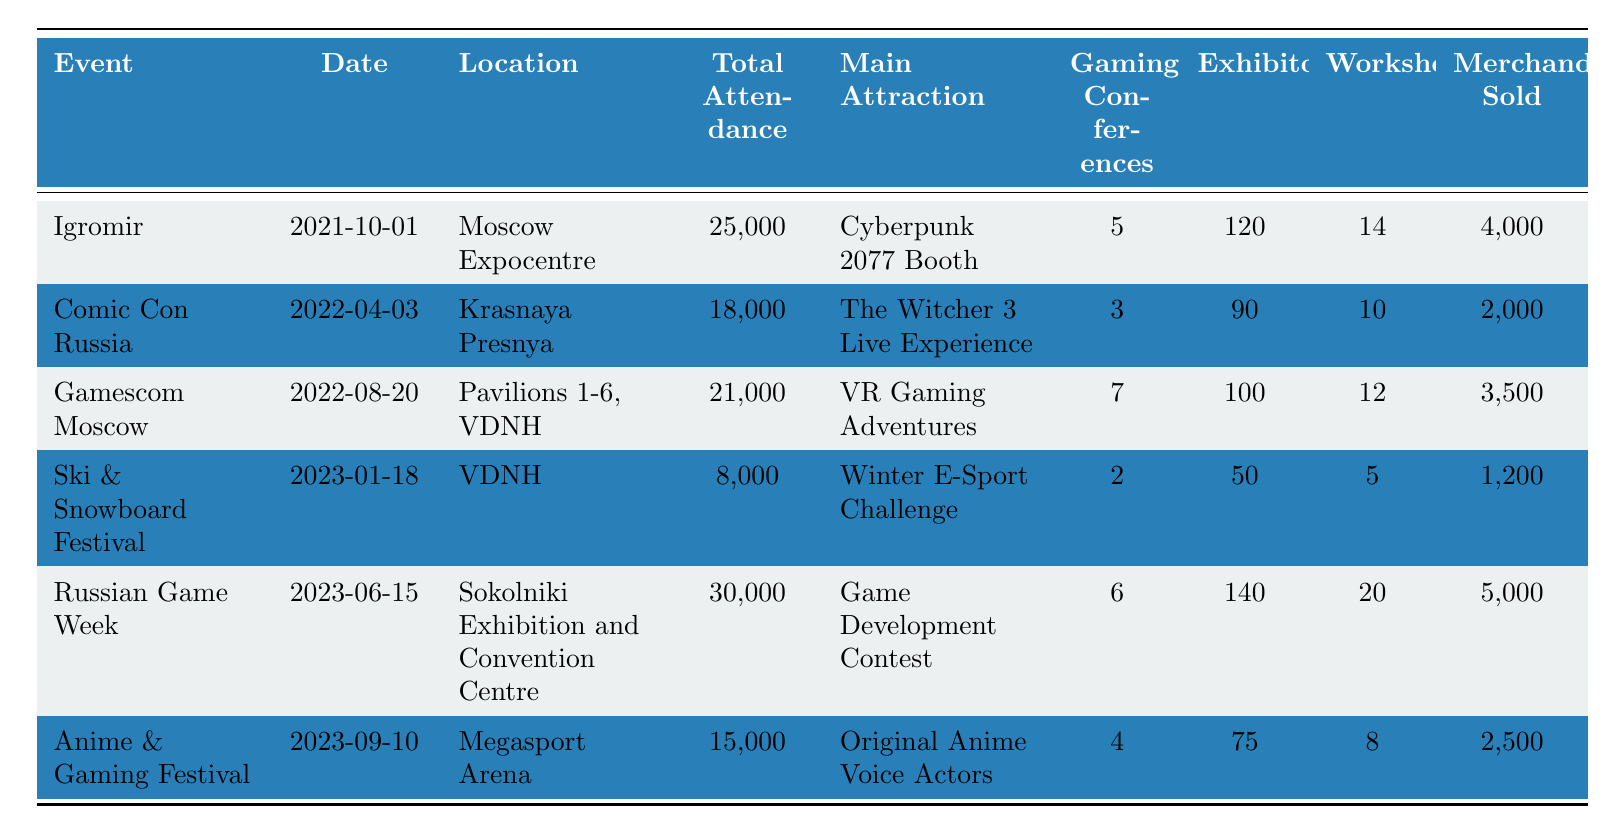What was the total attendance for the Russian Game Week? The table shows that the total attendance for the Russian Game Week, which took place on June 15, 2023, is listed as 30,000.
Answer: 30,000 Which event had the highest number of workshops? Looking at the table, the Russian Game Week has the highest number of workshops at 20, compared to other events.
Answer: 20 How many more exhibitors were present at Igromir compared to Anime & Gaming Festival? Igromir had 120 exhibitors while Anime & Gaming Festival had 75 exhibitors. The difference is 120 - 75 = 45 exhibitors.
Answer: 45 What is the average total attendance across all events listed? To find the average, sum the total attendance: 25,000 + 18,000 + 21,000 + 8,000 + 30,000 + 15,000 = 117,000. Divide by the number of events (6): 117,000 / 6 = 19,500.
Answer: 19,500 Did the Ski & Snowboard Festival have more exhibitors than the Anime & Gaming Festival? The Ski & Snowboard Festival had 50 exhibitors, while Anime & Gaming Festival had 75. Therefore, the Ski & Snowboard Festival had fewer exhibitors.
Answer: No Which event had the highest merchandise sold, and how much was it? The table reveals that the Russian Game Week had the highest merchandise sold at 5,000.
Answer: 5,000 How many gaming conferences were held at Gamescom Moscow compared to Comic Con Russia? Gamescom Moscow had 7 gaming conferences while Comic Con Russia had 3. The difference is 7 - 3 = 4 more conferences at Gamescom Moscow.
Answer: 4 What was the main attraction of the event held on April 3, 2022? Referring to the table, the main attraction for Comic Con Russia on April 3, 2022, was "The Witcher 3 Live Experience."
Answer: The Witcher 3 Live Experience Find the total number of workshops across all events in 2023. The workshops for 2023 events are Ski & Snowboard Festival (5), Russian Game Week (20), and Anime & Gaming Festival (8), so the total is 5 + 20 + 8 = 33 workshops.
Answer: 33 Is the total attendance for the Igromir event higher than that for Gamescom Moscow? Igromir had a total attendance of 25,000 while Gamescom Moscow had 21,000. Since 25,000 is greater than 21,000, Igromir had higher attendance.
Answer: Yes 